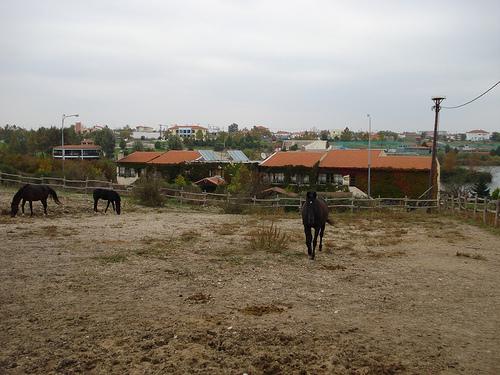Are the horses watching the people?
Answer briefly. No. Are the horses wild?
Keep it brief. No. Are these wild horses?
Be succinct. No. How many houses are in the picture?
Answer briefly. 5. What kind of dwellings are in the picture?
Quick response, please. Houses. Does this look like a ride?
Be succinct. No. Is this a barn?
Keep it brief. No. How many horses in this photo?
Answer briefly. 3. 